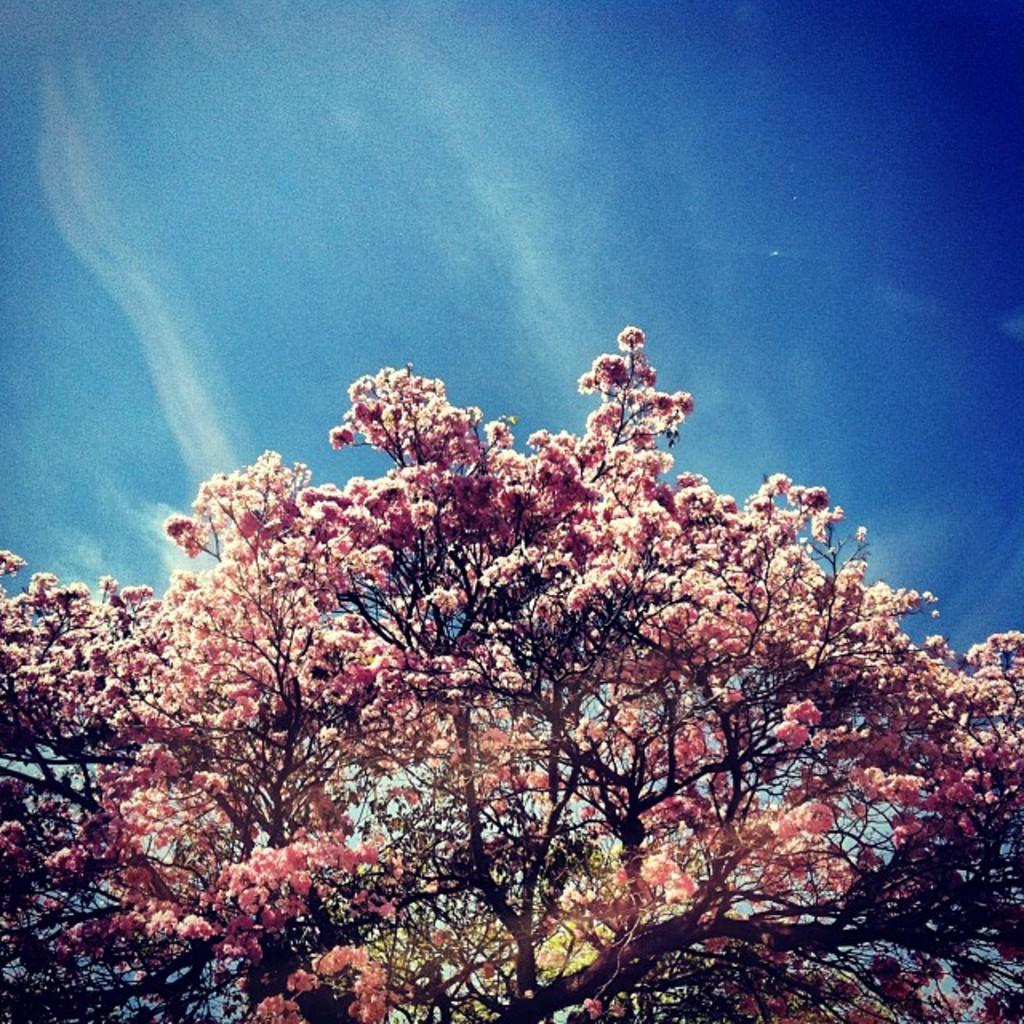What type of plants can be seen in the image? There are flowers in the image. What colors are the flowers? The flowers are in pink and brown colors. What can be seen in the background of the image? The sky is visible in the background of the image. What colors are the sky? The sky is in blue and white colors. Can you tell me how many waves are visible in the image? There are no waves present in the image; it features flowers and a blue sky. What type of shock can be seen in the image? There is no shock present in the image; it features flowers and a blue sky. 